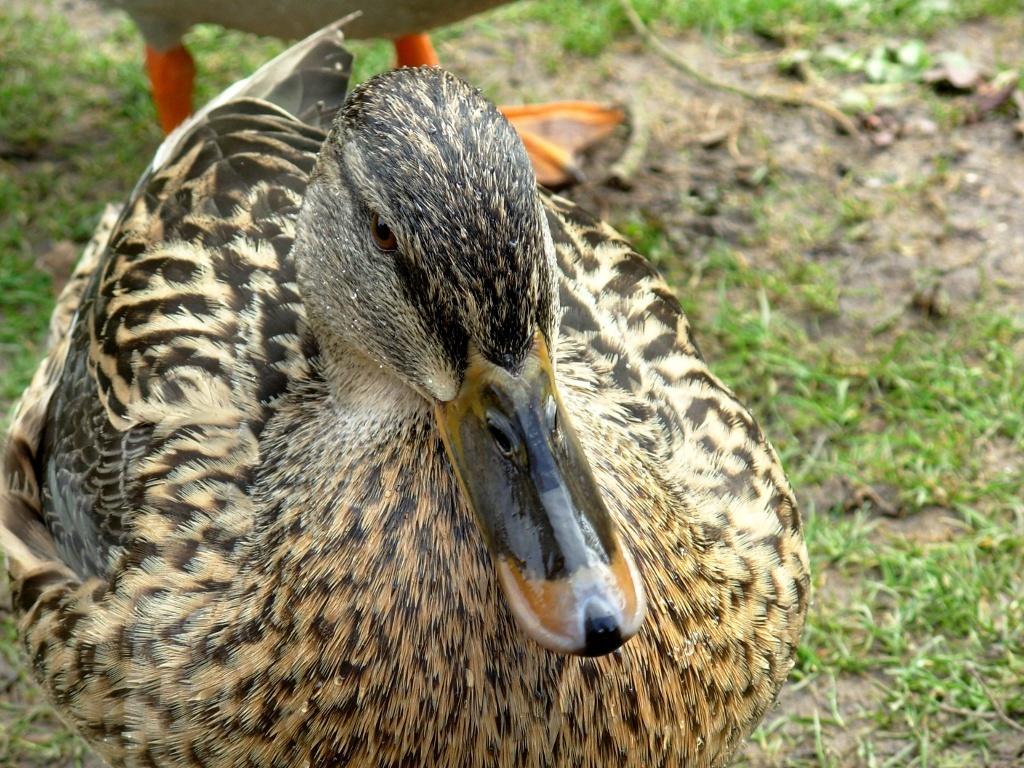How would you summarize this image in a sentence or two? In this image I can see grass ground and on it I can see two ducks. 